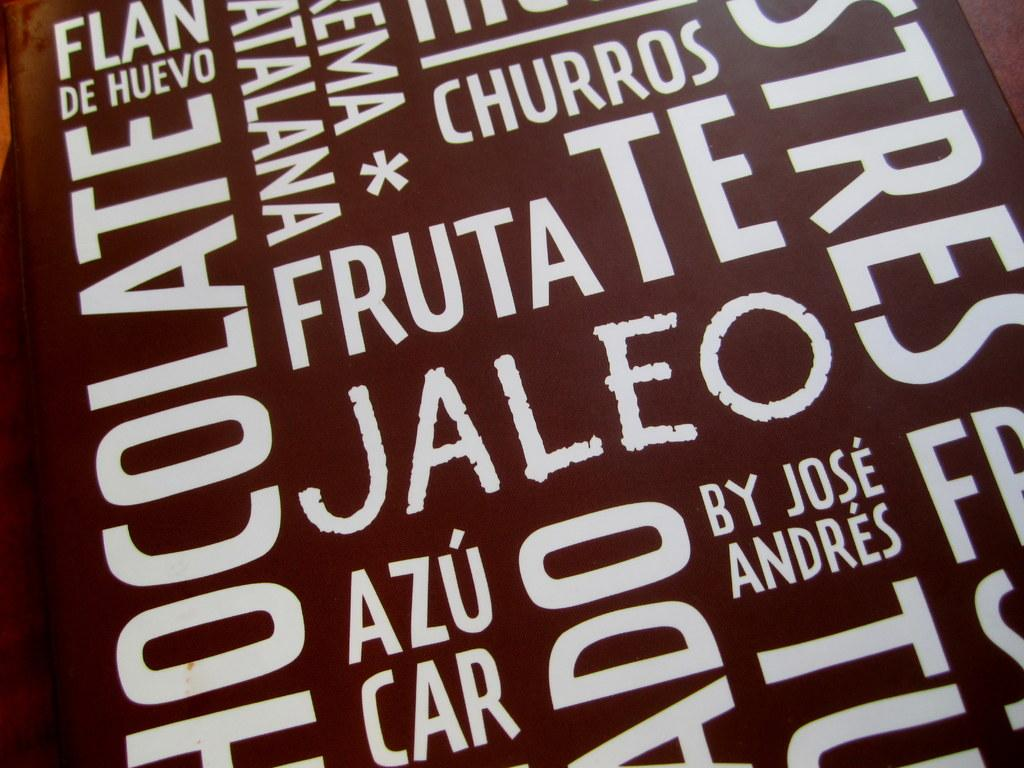<image>
Give a short and clear explanation of the subsequent image. A jumble of words, one of which is fruta. 